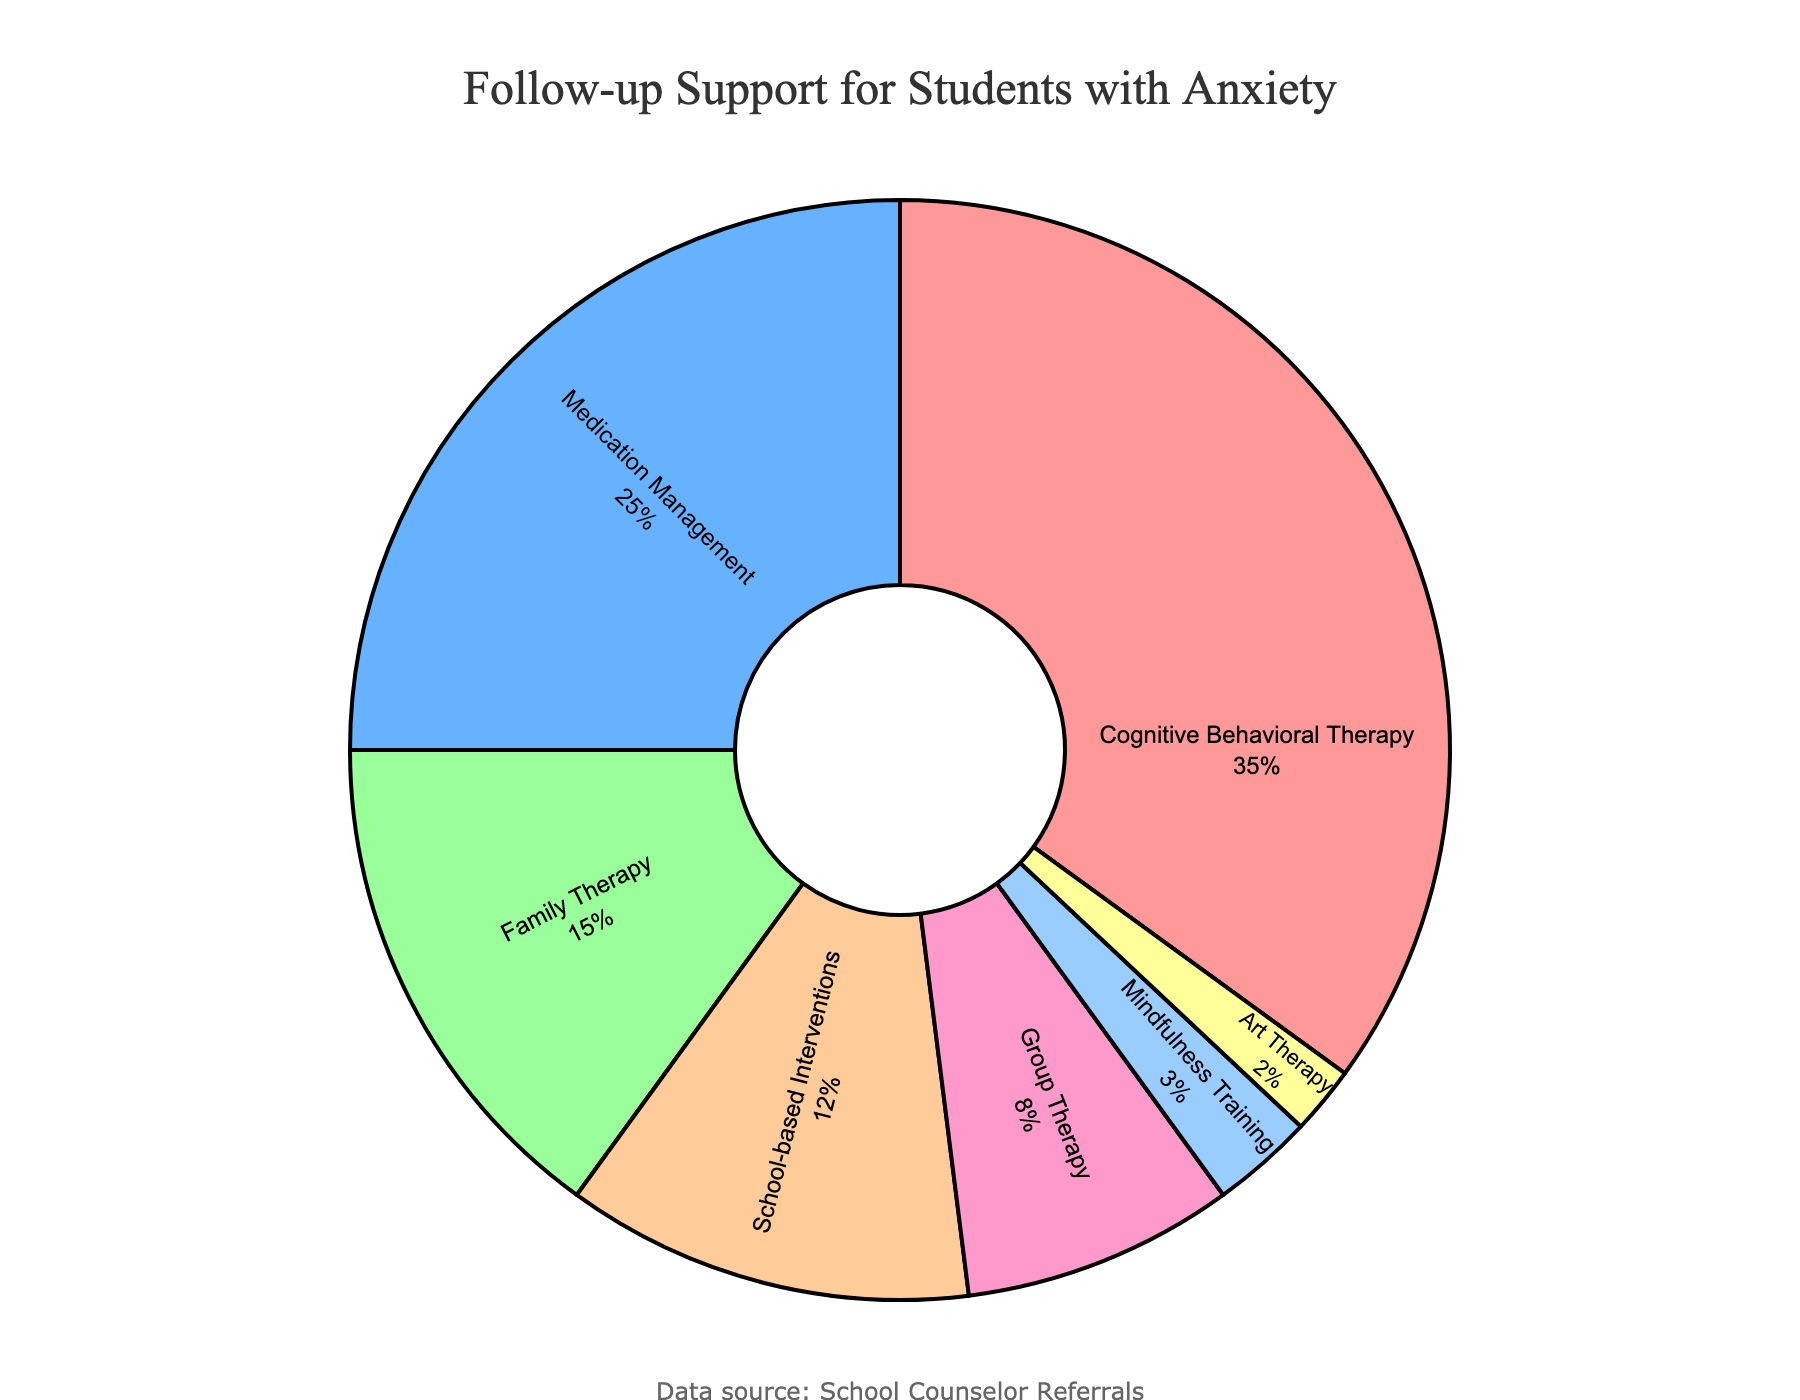What type of follow-up support receives the highest percentage of referrals? The highest percentage segment in the pie chart represents Cognitive Behavioral Therapy.
Answer: Cognitive Behavioral Therapy Which type of follow-up support has the second highest percentage? The second largest percentage segment in the pie chart corresponds to Medication Management.
Answer: Medication Management What proportion of students are referred to Family Therapy compared to those referred to School-based Interventions? Family Therapy accounts for 15% while School-based Interventions make up 12%, so Family Therapy has a higher proportion.
Answer: Family Therapy How much more percentage does Cognitive Behavioral Therapy receive compared to Group Therapy? Cognitive Behavioral Therapy accounts for 35% and Group Therapy accounts for 8%. The difference is 35% - 8% = 27%.
Answer: 27% What is the combined percentage of students receiving either School-based Interventions, Group Therapy, or Mindfulness Training? The combined percentage is 12% (School-based Interventions) + 8% (Group Therapy) + 3% (Mindfulness Training) = 23%.
Answer: 23% Which follow-up support type is the least referred to? The smallest segment in the pie chart represents Art Therapy, making it the least referred to.
Answer: Art Therapy Is the percentage of students referred to Family Therapy greater than those referred to Medication Management? Family Therapy accounts for 15%, whereas Medication Management accounts for 25%. Therefore, Family Therapy is not greater.
Answer: No What is the total percentage of students receiving Cognitive Behavioral Therapy and Medication Management combined? The total percentage is 35% (Cognitive Behavioral Therapy) + 25% (Medication Management) = 60%.
Answer: 60% Between which two follow-up support types is the percentage difference the smallest? The two follow-up types where the difference is the smallest are School-based Interventions (12%) and Group Therapy (8%), with a difference of 4%.
Answer: School-based Interventions and Group Therapy What is the percentage difference between the top and bottom follow-up support types? The top support type, Cognitive Behavioral Therapy, has 35%, and the bottom, Art Therapy, has 2%. The difference is 35% - 2% = 33%.
Answer: 33% 